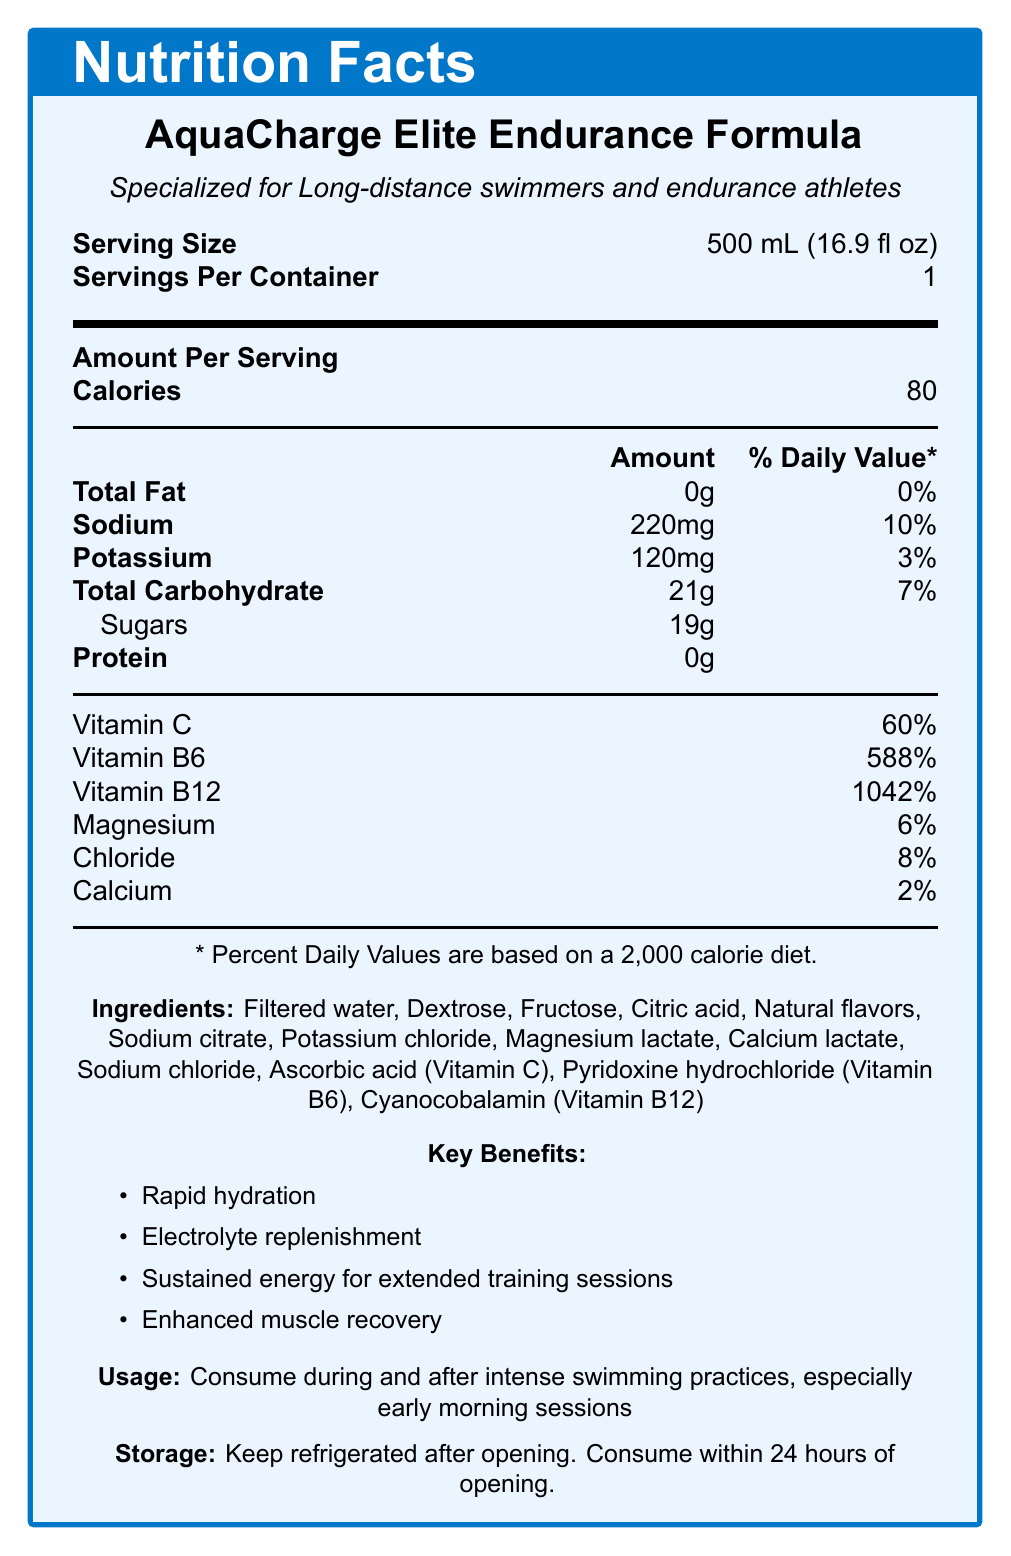what is the serving size? According to the document, the serving size is listed as 500 mL (16.9 fl oz).
Answer: 500 mL (16.9 fl oz) how many calories are in one serving of AquaCharge Elite Endurance Formula? The document states that there are 80 calories per serving.
Answer: 80 which vitamin is present at the highest percent daily value? A. Vitamin C B. Vitamin B6 C. Vitamin B12 D. Magnesium The percent daily value of Vitamin B12 is 1042%, which is the highest among the listed vitamins and minerals.
Answer: C how much sodium does AquaCharge Elite Endurance Formula contain per serving? The document states that there are 220mg of sodium per serving.
Answer: 220mg how many grams of total carbohydrates are in one serving? The document lists the total carbohydrate content as 21g per serving.
Answer: 21g does the sports drink contain any protein? The document indicates that the protein content per serving is 0g.
Answer: No what are the key benefits of consuming AquaCharge Elite Endurance Formula? The document lists these four key benefits under the "Key Benefits" section.
Answer: Rapid hydration, Electrolyte replenishment, Sustained energy for extended training sessions, Enhanced muscle recovery which ingredient is not mentioned in the AquaCharge Elite Endurance Formula? A. Dextrose B. Fructose C. Sodium citrate D. Potassium sulfate The document lists the ingredients including dextrose, fructose, and sodium citrate, but Potassium sulfate is not mentioned.
Answer: D is the drink specialized for long-distance swimmers and endurance athletes? The document specifies that the drink is specialized for long-distance swimmers and endurance athletes.
Answer: Yes what should users do with AquaCharge Elite Endurance Formula after opening it? The document advises to keep the drink refrigerated after opening and consume within 24 hours.
Answer: Keep refrigerated and consume within 24 hours what is the percent daily value of potassium in one serving? The document provides that the percent daily value for potassium is 3% per serving.
Answer: 3% summarize the main idea of the document. The document offers comprehensive details about AquaCharge Elite Endurance Formula, including nutritional information, benefits for endurance athletes, and guidelines for usage and storage.
Answer: This document is a Nutrition Facts Label for AquaCharge Elite Endurance Formula, an electrolyte-enhanced sports drink designed specially for long-distance swimmers and endurance athletes. It provides information on serving size, calories, nutritional content, key benefits, usage recommendations, and storage instructions. what is the main ingredient in the AquaCharge Elite Endurance Formula? The document lists multiple ingredients without indicating which is the primary or main one.
Answer: Cannot be determined 